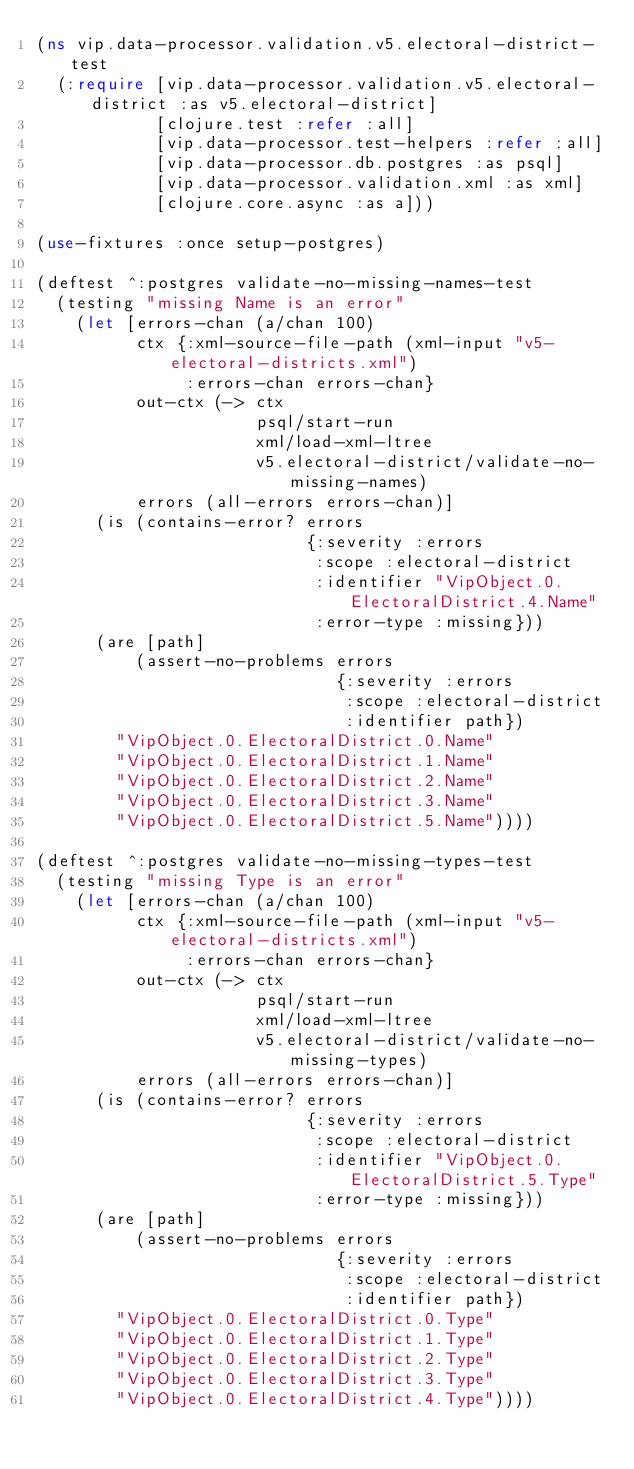Convert code to text. <code><loc_0><loc_0><loc_500><loc_500><_Clojure_>(ns vip.data-processor.validation.v5.electoral-district-test
  (:require [vip.data-processor.validation.v5.electoral-district :as v5.electoral-district]
            [clojure.test :refer :all]
            [vip.data-processor.test-helpers :refer :all]
            [vip.data-processor.db.postgres :as psql]
            [vip.data-processor.validation.xml :as xml]
            [clojure.core.async :as a]))

(use-fixtures :once setup-postgres)

(deftest ^:postgres validate-no-missing-names-test
  (testing "missing Name is an error"
    (let [errors-chan (a/chan 100)
          ctx {:xml-source-file-path (xml-input "v5-electoral-districts.xml")
               :errors-chan errors-chan}
          out-ctx (-> ctx
                      psql/start-run
                      xml/load-xml-ltree
                      v5.electoral-district/validate-no-missing-names)
          errors (all-errors errors-chan)]
      (is (contains-error? errors
                           {:severity :errors
                            :scope :electoral-district
                            :identifier "VipObject.0.ElectoralDistrict.4.Name"
                            :error-type :missing}))
      (are [path]
          (assert-no-problems errors
                              {:severity :errors
                               :scope :electoral-district
                               :identifier path})
        "VipObject.0.ElectoralDistrict.0.Name"
        "VipObject.0.ElectoralDistrict.1.Name"
        "VipObject.0.ElectoralDistrict.2.Name"
        "VipObject.0.ElectoralDistrict.3.Name"
        "VipObject.0.ElectoralDistrict.5.Name"))))

(deftest ^:postgres validate-no-missing-types-test
  (testing "missing Type is an error"
    (let [errors-chan (a/chan 100)
          ctx {:xml-source-file-path (xml-input "v5-electoral-districts.xml")
               :errors-chan errors-chan}
          out-ctx (-> ctx
                      psql/start-run
                      xml/load-xml-ltree
                      v5.electoral-district/validate-no-missing-types)
          errors (all-errors errors-chan)]
      (is (contains-error? errors
                           {:severity :errors
                            :scope :electoral-district
                            :identifier "VipObject.0.ElectoralDistrict.5.Type"
                            :error-type :missing}))
      (are [path]
          (assert-no-problems errors
                              {:severity :errors
                               :scope :electoral-district
                               :identifier path})
        "VipObject.0.ElectoralDistrict.0.Type"
        "VipObject.0.ElectoralDistrict.1.Type"
        "VipObject.0.ElectoralDistrict.2.Type"
        "VipObject.0.ElectoralDistrict.3.Type"
        "VipObject.0.ElectoralDistrict.4.Type"))))
</code> 